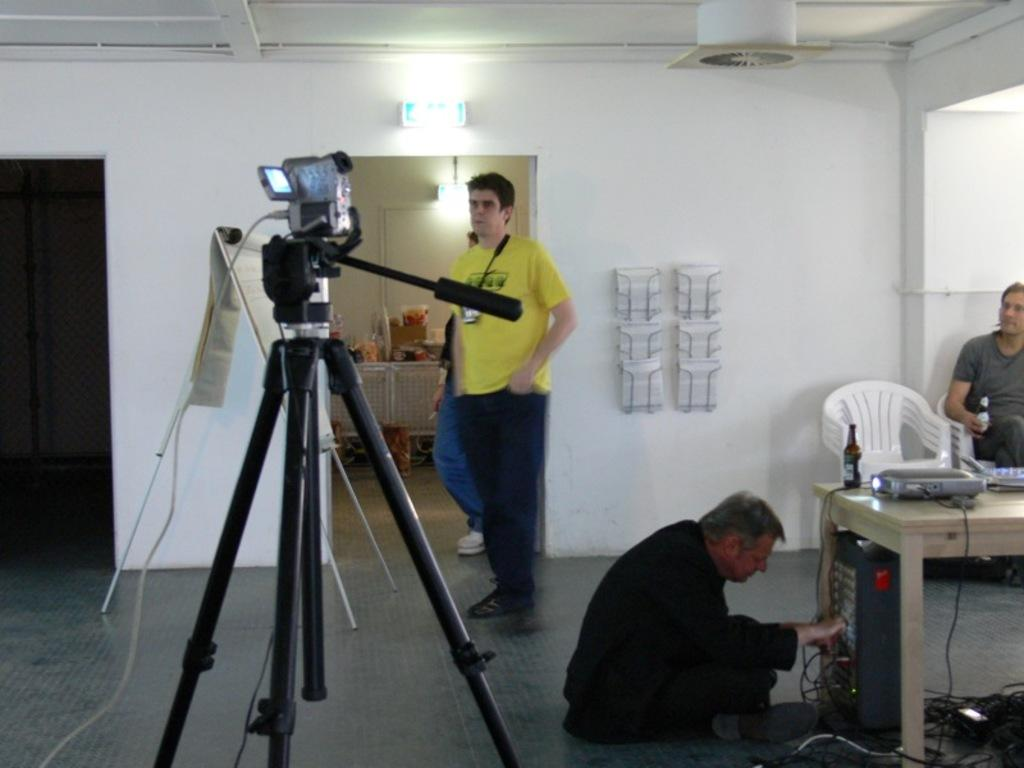What is the color of the wall in the image? The wall in the image is white. Who or what can be seen in the image? There are people in the image. What type of furniture is present in the image? There is a chair in the image. What device is used for capturing images in the image? There is a camera in the image. What other piece of furniture is present in the image? There is a table in the image. What is placed on the table in the image? There is a projector and a bottle on the table. What is the expert's opinion on the projector in the image? There is no expert present in the image, and therefore no expert opinion can be given. How many fingers are visible in the image? The number of fingers visible in the image cannot be determined from the provided facts. 